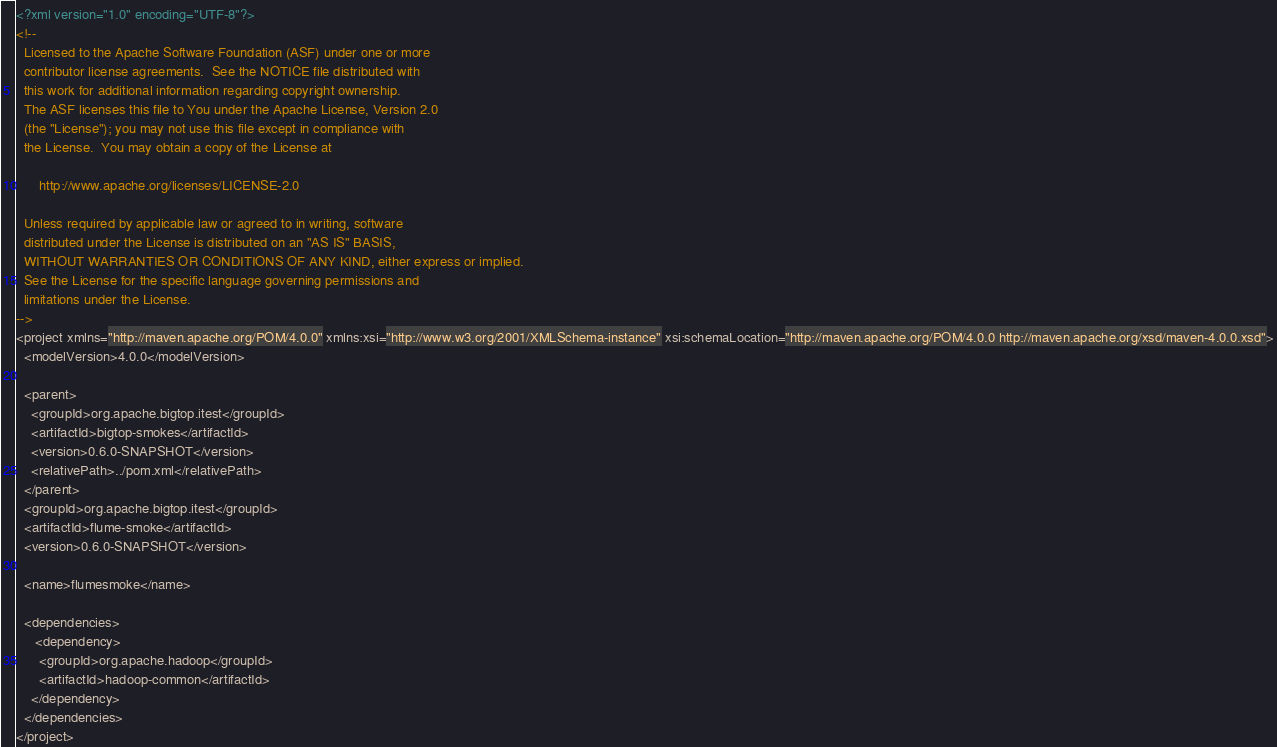<code> <loc_0><loc_0><loc_500><loc_500><_XML_><?xml version="1.0" encoding="UTF-8"?>
<!--
  Licensed to the Apache Software Foundation (ASF) under one or more
  contributor license agreements.  See the NOTICE file distributed with
  this work for additional information regarding copyright ownership.
  The ASF licenses this file to You under the Apache License, Version 2.0
  (the "License"); you may not use this file except in compliance with
  the License.  You may obtain a copy of the License at

      http://www.apache.org/licenses/LICENSE-2.0

  Unless required by applicable law or agreed to in writing, software
  distributed under the License is distributed on an "AS IS" BASIS,
  WITHOUT WARRANTIES OR CONDITIONS OF ANY KIND, either express or implied.
  See the License for the specific language governing permissions and
  limitations under the License.
-->
<project xmlns="http://maven.apache.org/POM/4.0.0" xmlns:xsi="http://www.w3.org/2001/XMLSchema-instance" xsi:schemaLocation="http://maven.apache.org/POM/4.0.0 http://maven.apache.org/xsd/maven-4.0.0.xsd">
  <modelVersion>4.0.0</modelVersion>

  <parent>
    <groupId>org.apache.bigtop.itest</groupId>
    <artifactId>bigtop-smokes</artifactId>
    <version>0.6.0-SNAPSHOT</version>
    <relativePath>../pom.xml</relativePath>
  </parent>
  <groupId>org.apache.bigtop.itest</groupId>
  <artifactId>flume-smoke</artifactId>
  <version>0.6.0-SNAPSHOT</version>

  <name>flumesmoke</name>

  <dependencies>
     <dependency>
      <groupId>org.apache.hadoop</groupId>
      <artifactId>hadoop-common</artifactId>
    </dependency>
  </dependencies>
</project>
</code> 